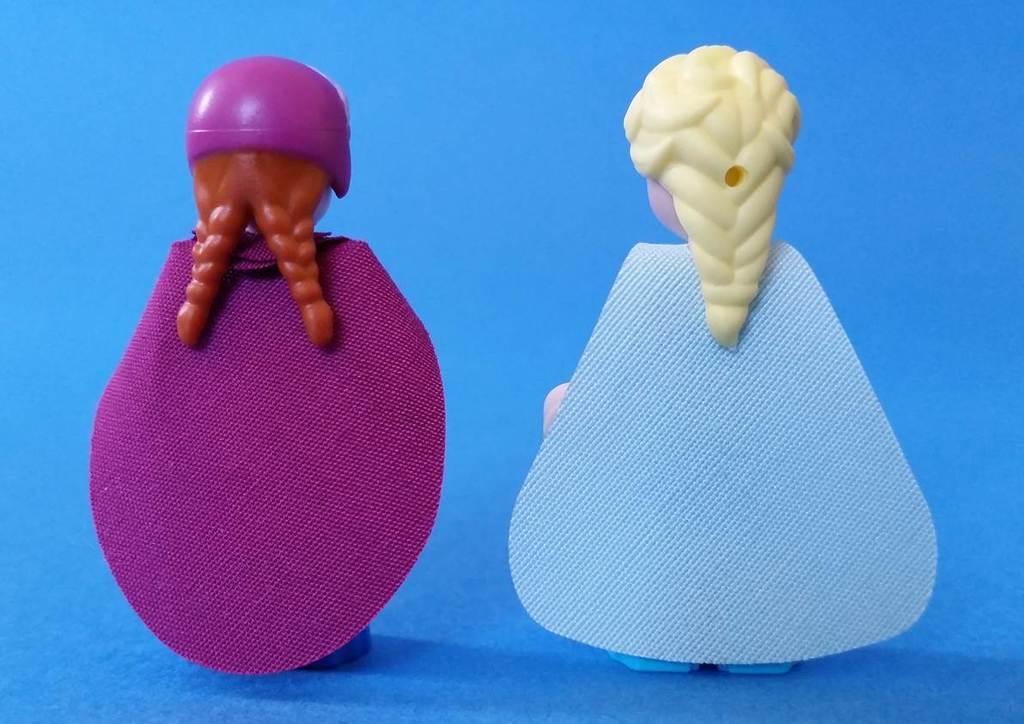Could you give a brief overview of what you see in this image? This picture describe about two small girl toy made up of plastic material with blue, purple color fabric. 